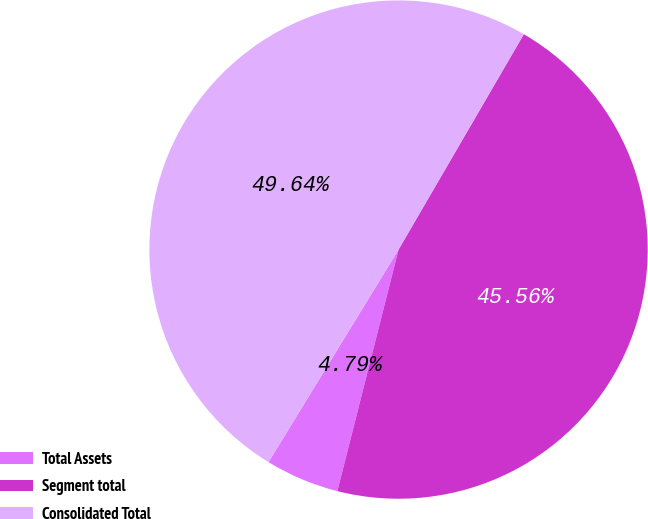Convert chart. <chart><loc_0><loc_0><loc_500><loc_500><pie_chart><fcel>Total Assets<fcel>Segment total<fcel>Consolidated Total<nl><fcel>4.79%<fcel>45.56%<fcel>49.64%<nl></chart> 